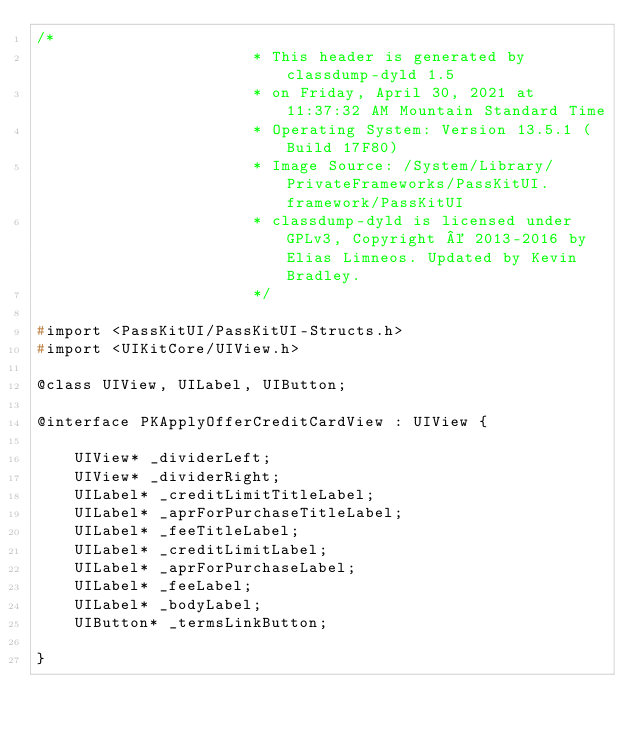Convert code to text. <code><loc_0><loc_0><loc_500><loc_500><_C_>/*
                       * This header is generated by classdump-dyld 1.5
                       * on Friday, April 30, 2021 at 11:37:32 AM Mountain Standard Time
                       * Operating System: Version 13.5.1 (Build 17F80)
                       * Image Source: /System/Library/PrivateFrameworks/PassKitUI.framework/PassKitUI
                       * classdump-dyld is licensed under GPLv3, Copyright © 2013-2016 by Elias Limneos. Updated by Kevin Bradley.
                       */

#import <PassKitUI/PassKitUI-Structs.h>
#import <UIKitCore/UIView.h>

@class UIView, UILabel, UIButton;

@interface PKApplyOfferCreditCardView : UIView {

	UIView* _dividerLeft;
	UIView* _dividerRight;
	UILabel* _creditLimitTitleLabel;
	UILabel* _aprForPurchaseTitleLabel;
	UILabel* _feeTitleLabel;
	UILabel* _creditLimitLabel;
	UILabel* _aprForPurchaseLabel;
	UILabel* _feeLabel;
	UILabel* _bodyLabel;
	UIButton* _termsLinkButton;

}
</code> 